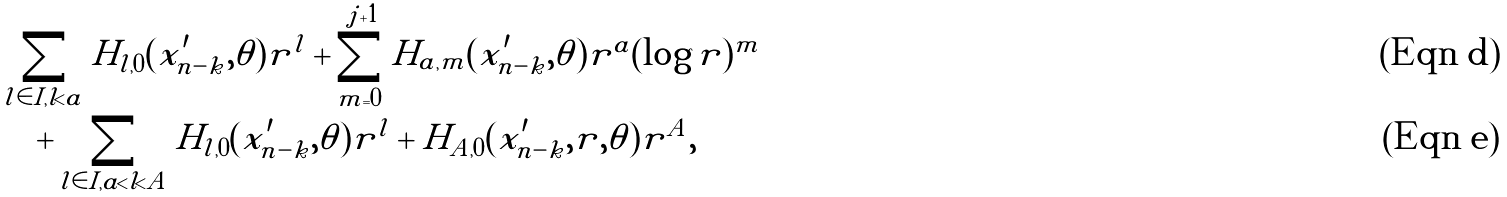Convert formula to latex. <formula><loc_0><loc_0><loc_500><loc_500>& \sum _ { l \in I , l < a } H _ { l , 0 } ( x _ { n - k } ^ { \prime } , \theta ) r ^ { l } + \sum _ { m = 0 } ^ { j + 1 } H _ { a , m } ( x _ { n - k } ^ { \prime } , \theta ) r ^ { a } ( \log r ) ^ { m } \\ & \quad + \sum _ { l \in I , a < l < A } H _ { l , 0 } ( x _ { n - k } ^ { \prime } , \theta ) r ^ { l } + H _ { A , 0 } ( x _ { n - k } ^ { \prime } , r , \theta ) r ^ { A } ,</formula> 